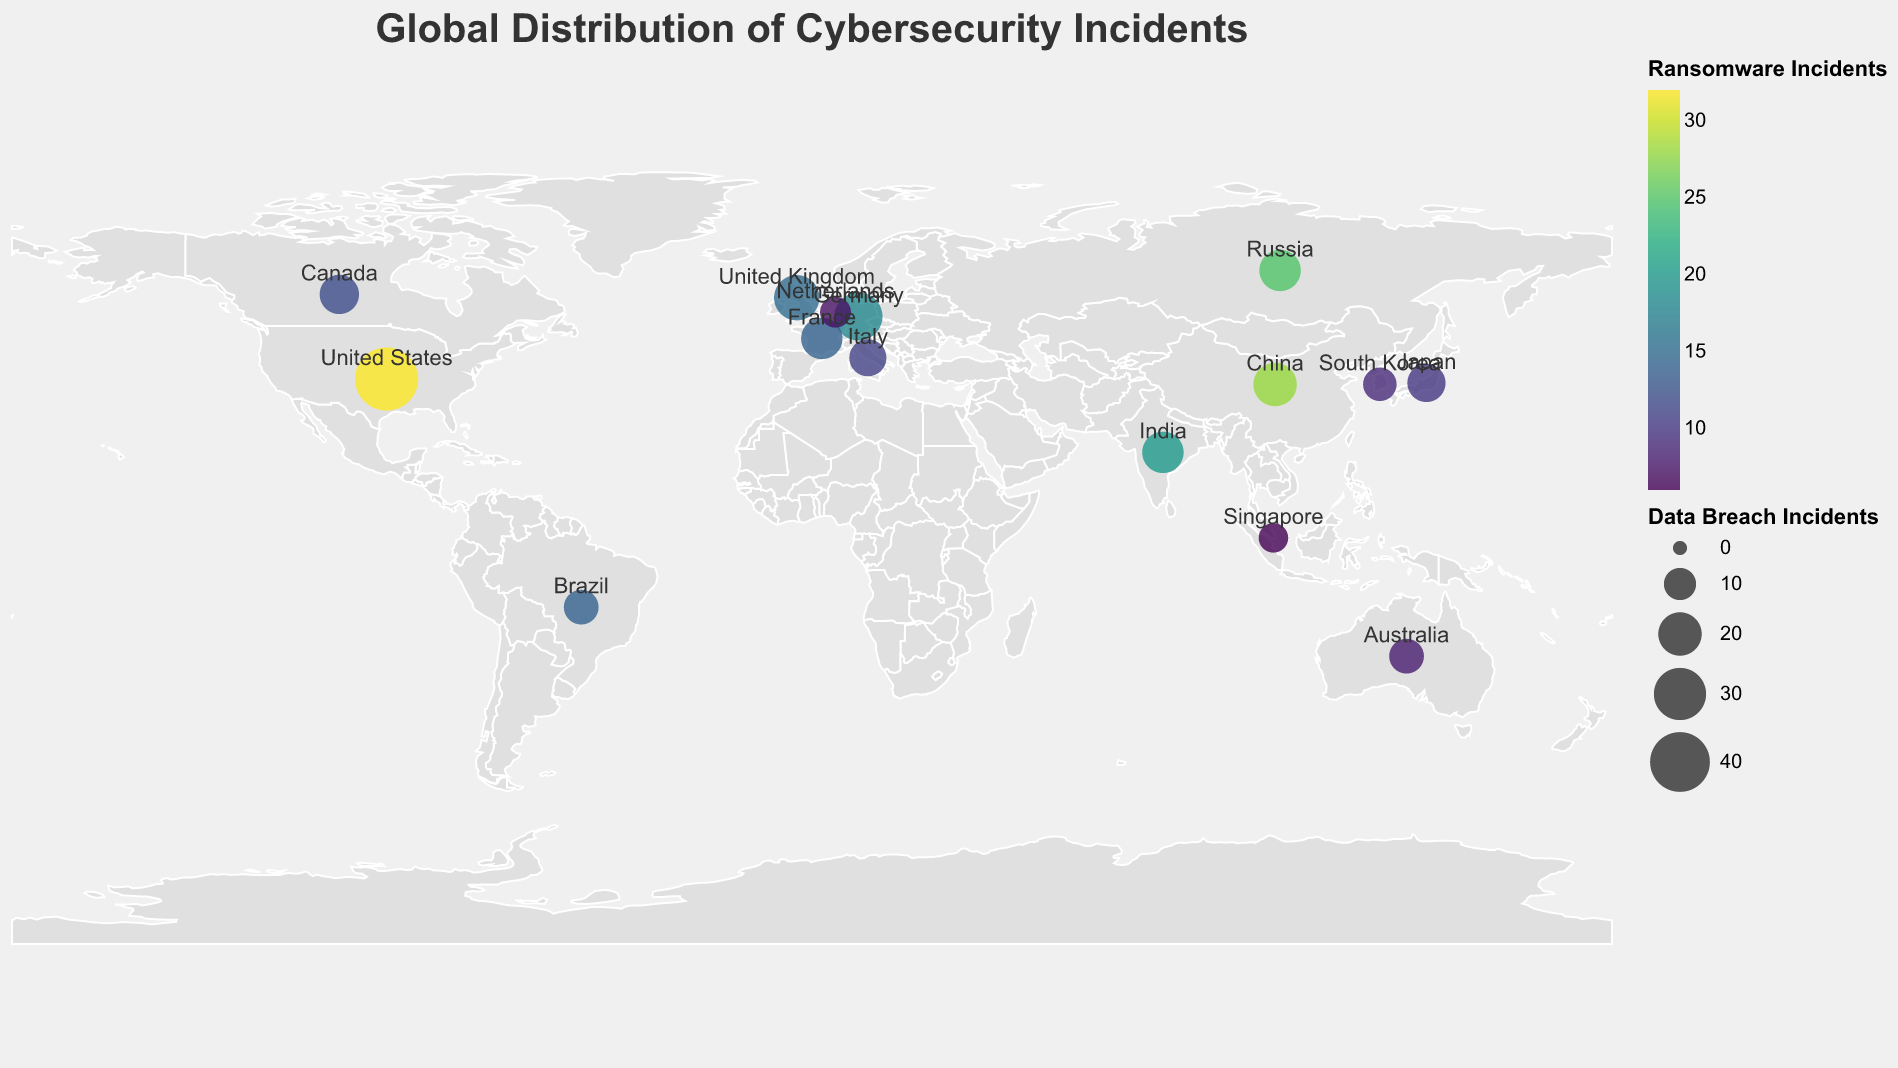What's the title of the figure? The title of the figure is displayed prominently at the top in larger font size and reads "Global Distribution of Cybersecurity Incidents".
Answer: Global Distribution of Cybersecurity Incidents Which country has the highest number of Data Breach incidents? By looking at the relative size of the circles and the tooltip information, the United States has the largest circles, representing the highest number of Data Breach incidents.
Answer: United States Which country has fewer Ransomware incidents, Australia or Canada? By referring to the color legend of Ransomware incidents and the tooltip, Australia has a Ransomware value of 8, whereas Canada has a value of 12. Thus, Australia has fewer incidents.
Answer: Australia How do Ransomware incidents in China compare to those in Russia? By consulting the color gradient representing Ransomware incidents and checking with the tooltip, China has 28 Ransomware incidents, and Russia has 25. Therefore, China has more Ransomware incidents than Russia.
Answer: China has more What is the total number of Phishing incidents in Japan and Singapore combined? Japan has 12 Phishing incidents and Singapore has 7, adding these together results in 19 Phishing incidents.
Answer: 19 Which country has the smallest Data Breach circle size on the plot? By observing the smallest circle sizes and validating using the tooltip, Singapore has the smallest Data Breach count of 8.
Answer: Singapore How does the frequency of DDoS attacks in India compare to that in Germany? By looking at the tooltip, India has 15 DDoS incidents, while Germany has 12 DDoS incidents, indicating that India has more DDoS attacks than Germany.
Answer: India has more What is the average number of Malware incidents in the United States, Canada, and Australia? The Malware incidents are 22 for the United States, 11 for Canada, and 7 for Australia. The sum is 22 + 11 + 7 = 40. The average is 40 / 3 = 13.33.
Answer: 13.33 What color on the plot represents the highest number of Ransomware incidents? The highest number of Ransomware incidents (32 in the United States) is indicated by the darkest color on the viridis color scale.
Answer: Darkest color Which country appears to have the same amount of Data Breach and Phishing incidents based on the tooltip? By checking the tooltip, Italy has 14 Data Breach incidents and 12 Phishing incidents, which, though not equal, are relatively close. Upon re-checking, India has 18 Data Breach and 25 Phishing incidents, equally close in visual appearance, but still not exactly equal. No country has identical values for both.
Answer: None 